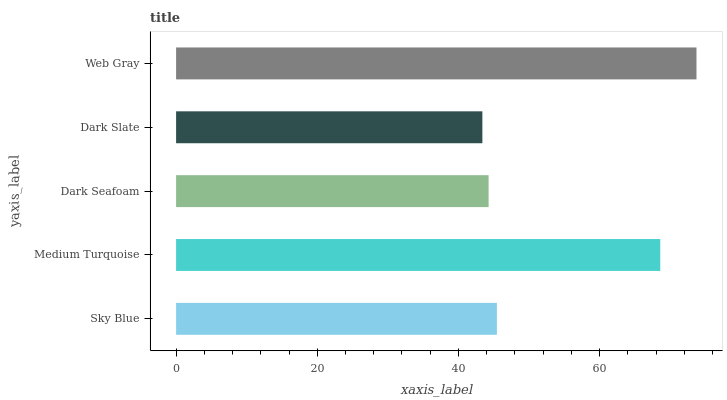Is Dark Slate the minimum?
Answer yes or no. Yes. Is Web Gray the maximum?
Answer yes or no. Yes. Is Medium Turquoise the minimum?
Answer yes or no. No. Is Medium Turquoise the maximum?
Answer yes or no. No. Is Medium Turquoise greater than Sky Blue?
Answer yes or no. Yes. Is Sky Blue less than Medium Turquoise?
Answer yes or no. Yes. Is Sky Blue greater than Medium Turquoise?
Answer yes or no. No. Is Medium Turquoise less than Sky Blue?
Answer yes or no. No. Is Sky Blue the high median?
Answer yes or no. Yes. Is Sky Blue the low median?
Answer yes or no. Yes. Is Dark Seafoam the high median?
Answer yes or no. No. Is Dark Slate the low median?
Answer yes or no. No. 